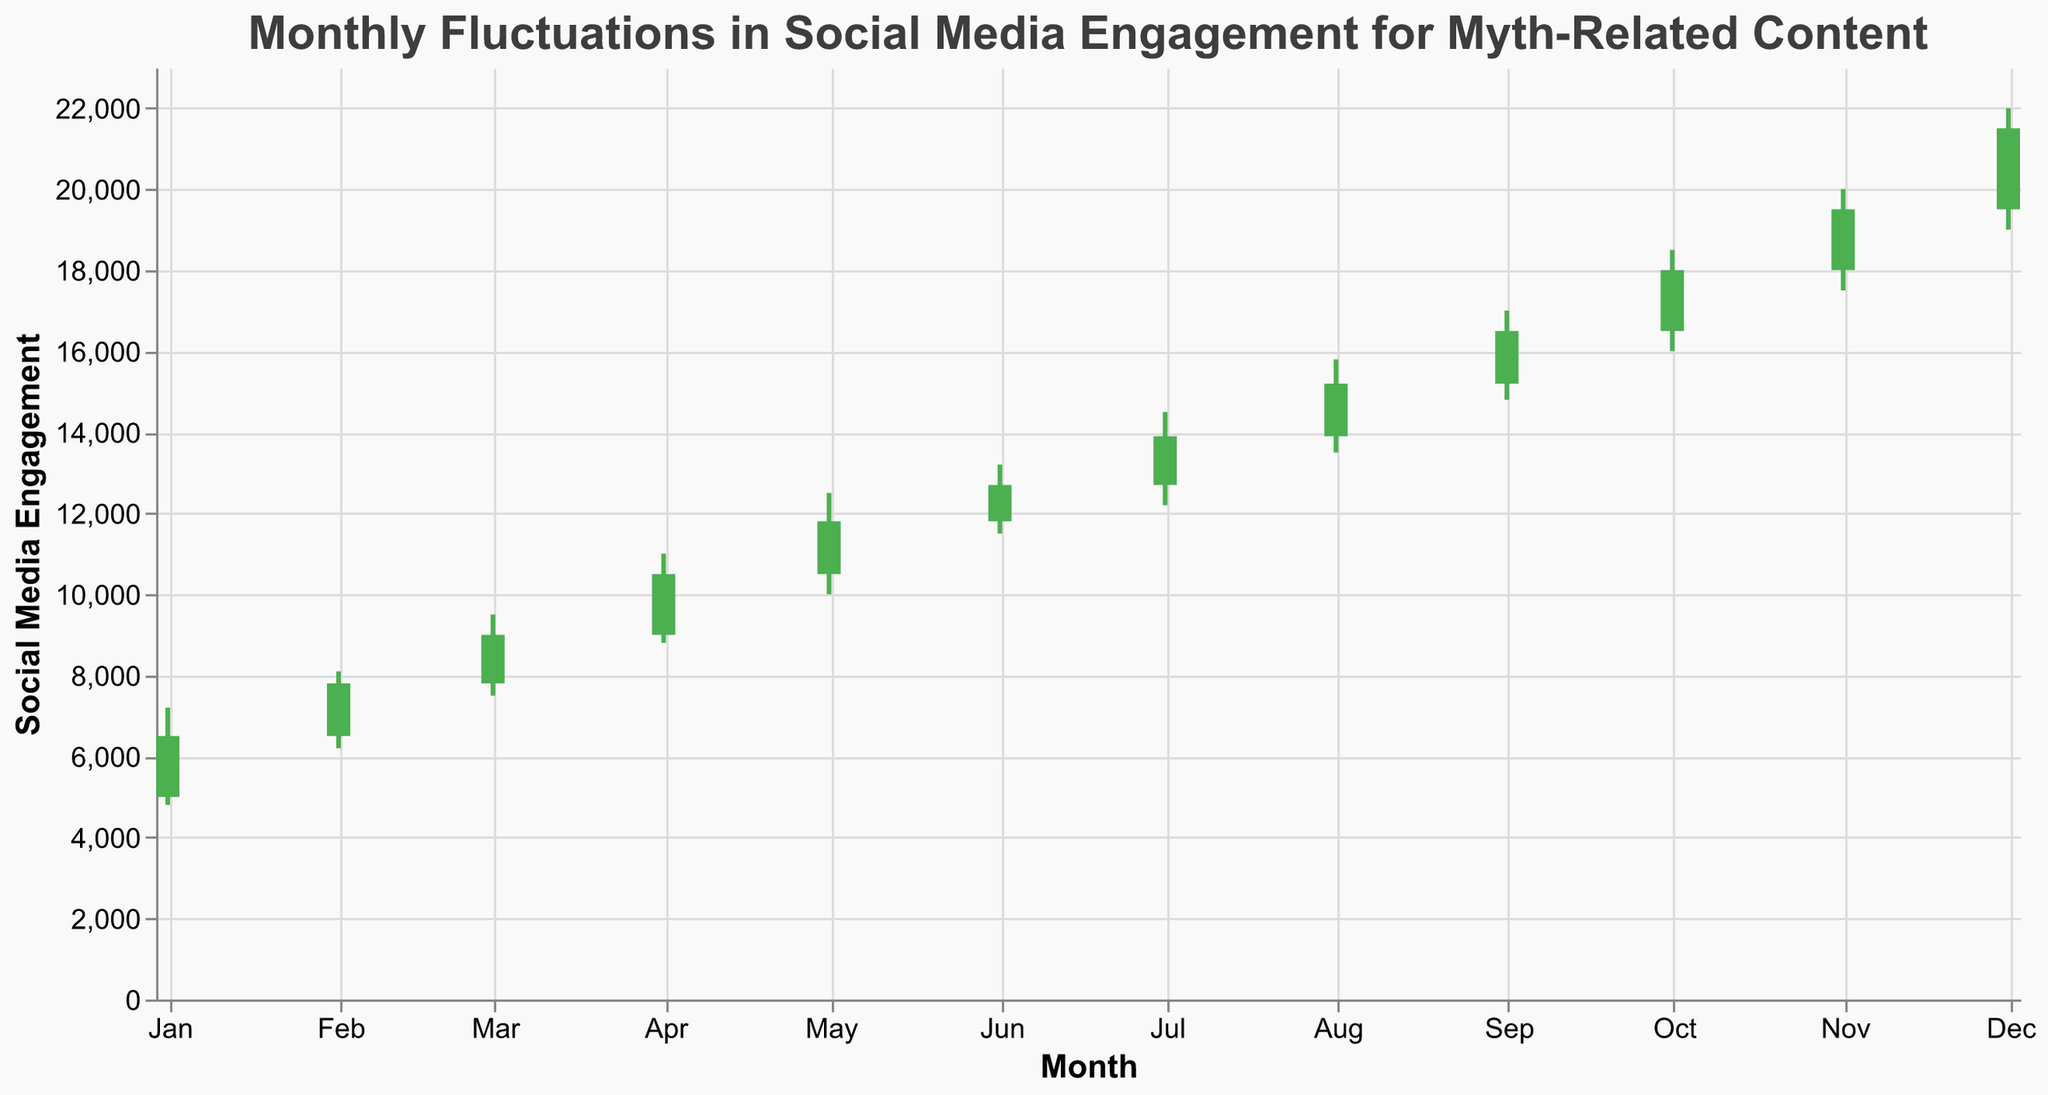What's the title of the chart? The title of the chart is displayed at the top center and summarized the content of the chart.
Answer: Monthly Fluctuations in Social Media Engagement for Myth-Related Content Which month had the highest closing social media engagement? By looking at the "Close" values of each month on the y-axis, we can see that the highest value is 21500 in December 2023.
Answer: December 2023 What is the color used for positive social media engagement changes (Open < Close)? The color green (#4CAF50) is used to indicate an increase in social media engagement where the closing value is higher than the opening value.
Answer: Green How did social media engagement change from July to August? For July, the engagement opened at 12700 and closed at 13900, showing an increase. For August, it opened at 13900 and closed at 15200, also an increase. Both months had rising engagements, with August having a higher gain.
Answer: Increased in both months Which myth had the smallest range of social media engagement in any given month? To find the smallest range, subtract the "Low" value from the "High" value for each month and compare. The myth with the smallest range is "Bigfoot" in January with a range of 2400 (7200 - 4800).
Answer: Bigfoot (January 2023) How much did social media engagement increase from the opening value to the closing value for the myth "Skinwalker" in November? Subtract the opening value from the closing value for November (19500 - 18000), resulting in an increase of 1500.
Answer: 1500 Did any myth experiences a month without any increase in social media engagement? We identify months where the "Close" values are less than or equal to the "Open" values. All monthly "Close" values are greater than the "Open" values, so there were no months without an increase.
Answer: No Which month had the highest volatility in its social media engagement range for the myth it featured? Volatility is the difference between "High" and "Low" values. The highest volatility is seen in December 2023 with a range of 3000 (22000 - 19000).
Answer: December 2023 Between March and April, which month had a higher monthly change in social media engagement for their respective myths? For March (Chupacabra), the change is 9000 - 7800 = 1200. For April (Yeti), the change is 10500 - 9000 = 1500. Therefore, April had a higher monthly change.
Answer: April 